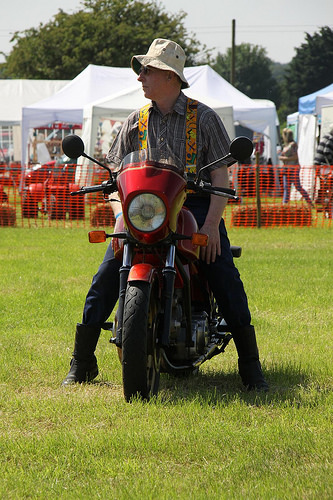<image>
Is there a cap on the bike? No. The cap is not positioned on the bike. They may be near each other, but the cap is not supported by or resting on top of the bike. 